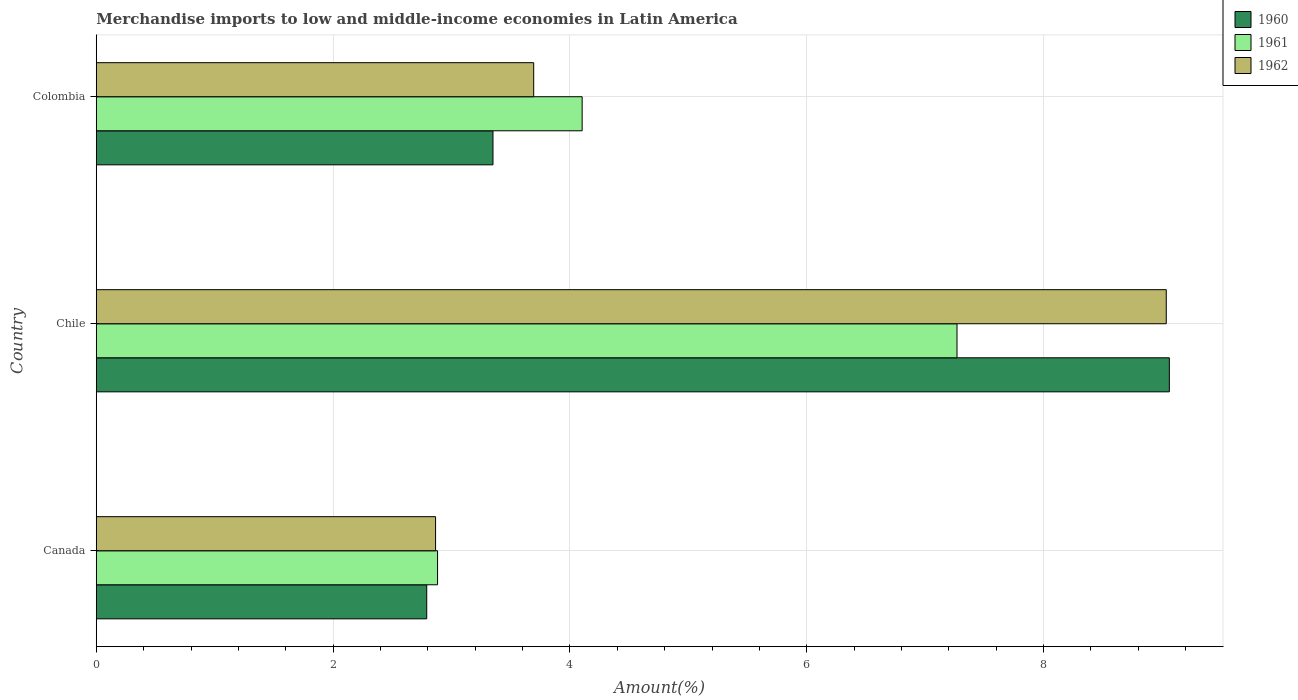How many different coloured bars are there?
Give a very brief answer. 3. How many groups of bars are there?
Your answer should be compact. 3. Are the number of bars per tick equal to the number of legend labels?
Offer a terse response. Yes. Are the number of bars on each tick of the Y-axis equal?
Keep it short and to the point. Yes. How many bars are there on the 3rd tick from the top?
Make the answer very short. 3. How many bars are there on the 2nd tick from the bottom?
Give a very brief answer. 3. What is the label of the 1st group of bars from the top?
Offer a terse response. Colombia. In how many cases, is the number of bars for a given country not equal to the number of legend labels?
Provide a short and direct response. 0. What is the percentage of amount earned from merchandise imports in 1960 in Chile?
Offer a very short reply. 9.06. Across all countries, what is the maximum percentage of amount earned from merchandise imports in 1962?
Make the answer very short. 9.04. Across all countries, what is the minimum percentage of amount earned from merchandise imports in 1961?
Your response must be concise. 2.88. What is the total percentage of amount earned from merchandise imports in 1962 in the graph?
Give a very brief answer. 15.6. What is the difference between the percentage of amount earned from merchandise imports in 1960 in Canada and that in Chile?
Ensure brevity in your answer.  -6.27. What is the difference between the percentage of amount earned from merchandise imports in 1960 in Chile and the percentage of amount earned from merchandise imports in 1961 in Colombia?
Your response must be concise. 4.96. What is the average percentage of amount earned from merchandise imports in 1960 per country?
Your answer should be compact. 5.07. What is the difference between the percentage of amount earned from merchandise imports in 1960 and percentage of amount earned from merchandise imports in 1962 in Canada?
Keep it short and to the point. -0.07. What is the ratio of the percentage of amount earned from merchandise imports in 1961 in Canada to that in Chile?
Provide a short and direct response. 0.4. Is the percentage of amount earned from merchandise imports in 1961 in Canada less than that in Chile?
Your response must be concise. Yes. Is the difference between the percentage of amount earned from merchandise imports in 1960 in Canada and Chile greater than the difference between the percentage of amount earned from merchandise imports in 1962 in Canada and Chile?
Provide a short and direct response. No. What is the difference between the highest and the second highest percentage of amount earned from merchandise imports in 1960?
Keep it short and to the point. 5.71. What is the difference between the highest and the lowest percentage of amount earned from merchandise imports in 1961?
Your response must be concise. 4.39. In how many countries, is the percentage of amount earned from merchandise imports in 1961 greater than the average percentage of amount earned from merchandise imports in 1961 taken over all countries?
Provide a succinct answer. 1. What does the 1st bar from the bottom in Chile represents?
Your answer should be compact. 1960. Are all the bars in the graph horizontal?
Provide a succinct answer. Yes. Are the values on the major ticks of X-axis written in scientific E-notation?
Give a very brief answer. No. Does the graph contain any zero values?
Your response must be concise. No. How many legend labels are there?
Ensure brevity in your answer.  3. What is the title of the graph?
Ensure brevity in your answer.  Merchandise imports to low and middle-income economies in Latin America. Does "1986" appear as one of the legend labels in the graph?
Make the answer very short. No. What is the label or title of the X-axis?
Offer a terse response. Amount(%). What is the Amount(%) of 1960 in Canada?
Your answer should be compact. 2.79. What is the Amount(%) of 1961 in Canada?
Provide a succinct answer. 2.88. What is the Amount(%) in 1962 in Canada?
Provide a short and direct response. 2.87. What is the Amount(%) in 1960 in Chile?
Make the answer very short. 9.06. What is the Amount(%) in 1961 in Chile?
Offer a terse response. 7.27. What is the Amount(%) of 1962 in Chile?
Your answer should be compact. 9.04. What is the Amount(%) of 1960 in Colombia?
Ensure brevity in your answer.  3.35. What is the Amount(%) of 1961 in Colombia?
Your answer should be compact. 4.1. What is the Amount(%) of 1962 in Colombia?
Offer a very short reply. 3.69. Across all countries, what is the maximum Amount(%) of 1960?
Keep it short and to the point. 9.06. Across all countries, what is the maximum Amount(%) of 1961?
Your answer should be very brief. 7.27. Across all countries, what is the maximum Amount(%) in 1962?
Make the answer very short. 9.04. Across all countries, what is the minimum Amount(%) of 1960?
Offer a very short reply. 2.79. Across all countries, what is the minimum Amount(%) of 1961?
Ensure brevity in your answer.  2.88. Across all countries, what is the minimum Amount(%) of 1962?
Give a very brief answer. 2.87. What is the total Amount(%) of 1960 in the graph?
Your answer should be compact. 15.2. What is the total Amount(%) of 1961 in the graph?
Provide a succinct answer. 14.25. What is the total Amount(%) of 1962 in the graph?
Your response must be concise. 15.6. What is the difference between the Amount(%) in 1960 in Canada and that in Chile?
Your response must be concise. -6.27. What is the difference between the Amount(%) of 1961 in Canada and that in Chile?
Make the answer very short. -4.39. What is the difference between the Amount(%) of 1962 in Canada and that in Chile?
Keep it short and to the point. -6.17. What is the difference between the Amount(%) in 1960 in Canada and that in Colombia?
Offer a very short reply. -0.56. What is the difference between the Amount(%) in 1961 in Canada and that in Colombia?
Give a very brief answer. -1.22. What is the difference between the Amount(%) in 1962 in Canada and that in Colombia?
Provide a succinct answer. -0.83. What is the difference between the Amount(%) of 1960 in Chile and that in Colombia?
Provide a succinct answer. 5.71. What is the difference between the Amount(%) of 1961 in Chile and that in Colombia?
Your response must be concise. 3.17. What is the difference between the Amount(%) of 1962 in Chile and that in Colombia?
Offer a terse response. 5.34. What is the difference between the Amount(%) in 1960 in Canada and the Amount(%) in 1961 in Chile?
Make the answer very short. -4.48. What is the difference between the Amount(%) of 1960 in Canada and the Amount(%) of 1962 in Chile?
Your response must be concise. -6.25. What is the difference between the Amount(%) of 1961 in Canada and the Amount(%) of 1962 in Chile?
Ensure brevity in your answer.  -6.15. What is the difference between the Amount(%) of 1960 in Canada and the Amount(%) of 1961 in Colombia?
Offer a very short reply. -1.31. What is the difference between the Amount(%) in 1960 in Canada and the Amount(%) in 1962 in Colombia?
Keep it short and to the point. -0.9. What is the difference between the Amount(%) in 1961 in Canada and the Amount(%) in 1962 in Colombia?
Provide a succinct answer. -0.81. What is the difference between the Amount(%) in 1960 in Chile and the Amount(%) in 1961 in Colombia?
Keep it short and to the point. 4.96. What is the difference between the Amount(%) of 1960 in Chile and the Amount(%) of 1962 in Colombia?
Give a very brief answer. 5.37. What is the difference between the Amount(%) of 1961 in Chile and the Amount(%) of 1962 in Colombia?
Provide a short and direct response. 3.57. What is the average Amount(%) in 1960 per country?
Provide a succinct answer. 5.07. What is the average Amount(%) in 1961 per country?
Offer a terse response. 4.75. What is the average Amount(%) of 1962 per country?
Offer a very short reply. 5.2. What is the difference between the Amount(%) in 1960 and Amount(%) in 1961 in Canada?
Keep it short and to the point. -0.09. What is the difference between the Amount(%) of 1960 and Amount(%) of 1962 in Canada?
Offer a very short reply. -0.07. What is the difference between the Amount(%) in 1961 and Amount(%) in 1962 in Canada?
Your response must be concise. 0.02. What is the difference between the Amount(%) of 1960 and Amount(%) of 1961 in Chile?
Your answer should be very brief. 1.79. What is the difference between the Amount(%) in 1960 and Amount(%) in 1962 in Chile?
Ensure brevity in your answer.  0.03. What is the difference between the Amount(%) in 1961 and Amount(%) in 1962 in Chile?
Ensure brevity in your answer.  -1.77. What is the difference between the Amount(%) in 1960 and Amount(%) in 1961 in Colombia?
Your response must be concise. -0.75. What is the difference between the Amount(%) of 1960 and Amount(%) of 1962 in Colombia?
Your answer should be very brief. -0.34. What is the difference between the Amount(%) of 1961 and Amount(%) of 1962 in Colombia?
Offer a very short reply. 0.41. What is the ratio of the Amount(%) in 1960 in Canada to that in Chile?
Offer a very short reply. 0.31. What is the ratio of the Amount(%) of 1961 in Canada to that in Chile?
Offer a very short reply. 0.4. What is the ratio of the Amount(%) of 1962 in Canada to that in Chile?
Provide a short and direct response. 0.32. What is the ratio of the Amount(%) of 1960 in Canada to that in Colombia?
Offer a very short reply. 0.83. What is the ratio of the Amount(%) in 1961 in Canada to that in Colombia?
Provide a succinct answer. 0.7. What is the ratio of the Amount(%) of 1962 in Canada to that in Colombia?
Your answer should be very brief. 0.78. What is the ratio of the Amount(%) of 1960 in Chile to that in Colombia?
Your answer should be very brief. 2.7. What is the ratio of the Amount(%) in 1961 in Chile to that in Colombia?
Offer a terse response. 1.77. What is the ratio of the Amount(%) of 1962 in Chile to that in Colombia?
Give a very brief answer. 2.45. What is the difference between the highest and the second highest Amount(%) of 1960?
Make the answer very short. 5.71. What is the difference between the highest and the second highest Amount(%) of 1961?
Your answer should be compact. 3.17. What is the difference between the highest and the second highest Amount(%) of 1962?
Ensure brevity in your answer.  5.34. What is the difference between the highest and the lowest Amount(%) of 1960?
Provide a short and direct response. 6.27. What is the difference between the highest and the lowest Amount(%) in 1961?
Your response must be concise. 4.39. What is the difference between the highest and the lowest Amount(%) in 1962?
Your response must be concise. 6.17. 